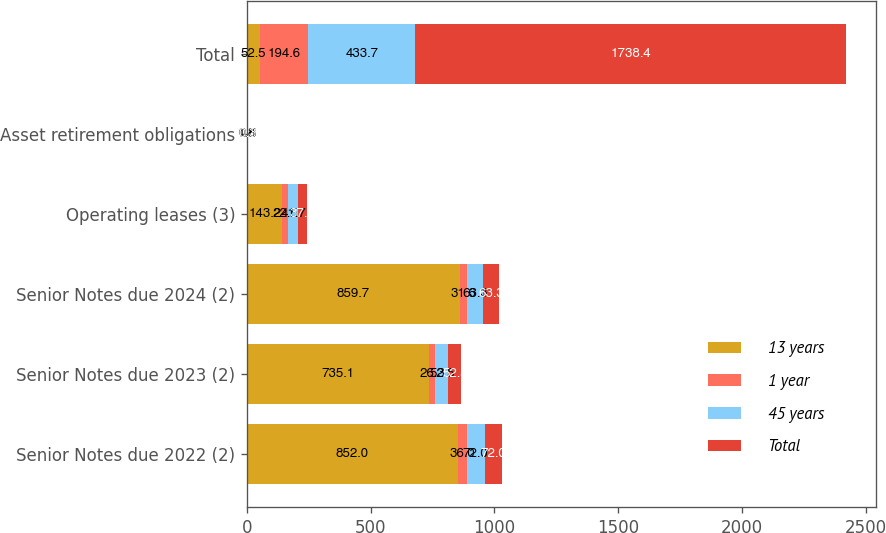Convert chart to OTSL. <chart><loc_0><loc_0><loc_500><loc_500><stacked_bar_chart><ecel><fcel>Senior Notes due 2022 (2)<fcel>Senior Notes due 2023 (2)<fcel>Senior Notes due 2024 (2)<fcel>Operating leases (3)<fcel>Asset retirement obligations<fcel>Total<nl><fcel>13 years<fcel>852<fcel>735.1<fcel>859.7<fcel>143.2<fcel>1.8<fcel>52.5<nl><fcel>1 year<fcel>36<fcel>26.3<fcel>31.6<fcel>22.5<fcel>0.8<fcel>194.6<nl><fcel>45 years<fcel>72<fcel>52.5<fcel>63.3<fcel>41.7<fcel>0.5<fcel>433.7<nl><fcel>Total<fcel>72<fcel>52.5<fcel>63.3<fcel>37.1<fcel>0.3<fcel>1738.4<nl></chart> 